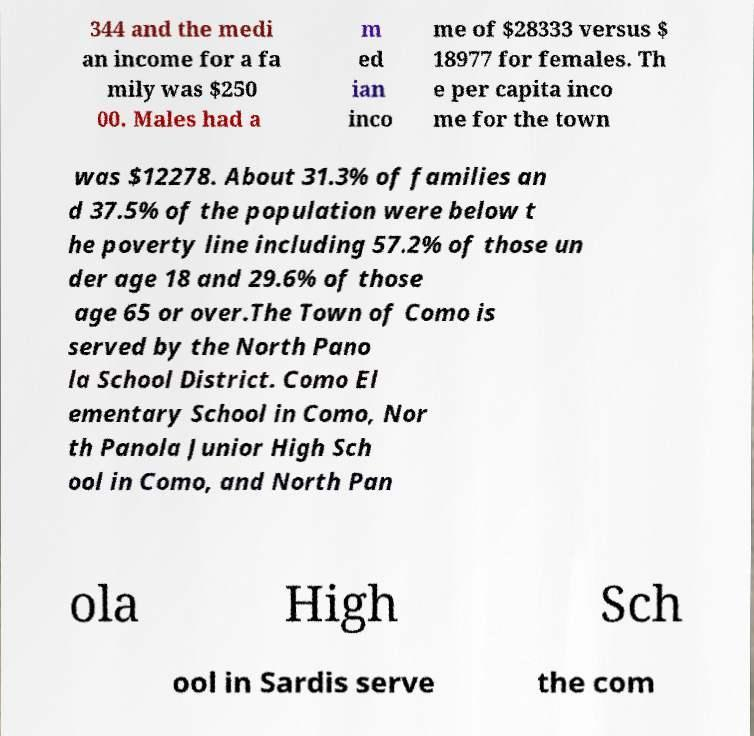What messages or text are displayed in this image? I need them in a readable, typed format. 344 and the medi an income for a fa mily was $250 00. Males had a m ed ian inco me of $28333 versus $ 18977 for females. Th e per capita inco me for the town was $12278. About 31.3% of families an d 37.5% of the population were below t he poverty line including 57.2% of those un der age 18 and 29.6% of those age 65 or over.The Town of Como is served by the North Pano la School District. Como El ementary School in Como, Nor th Panola Junior High Sch ool in Como, and North Pan ola High Sch ool in Sardis serve the com 